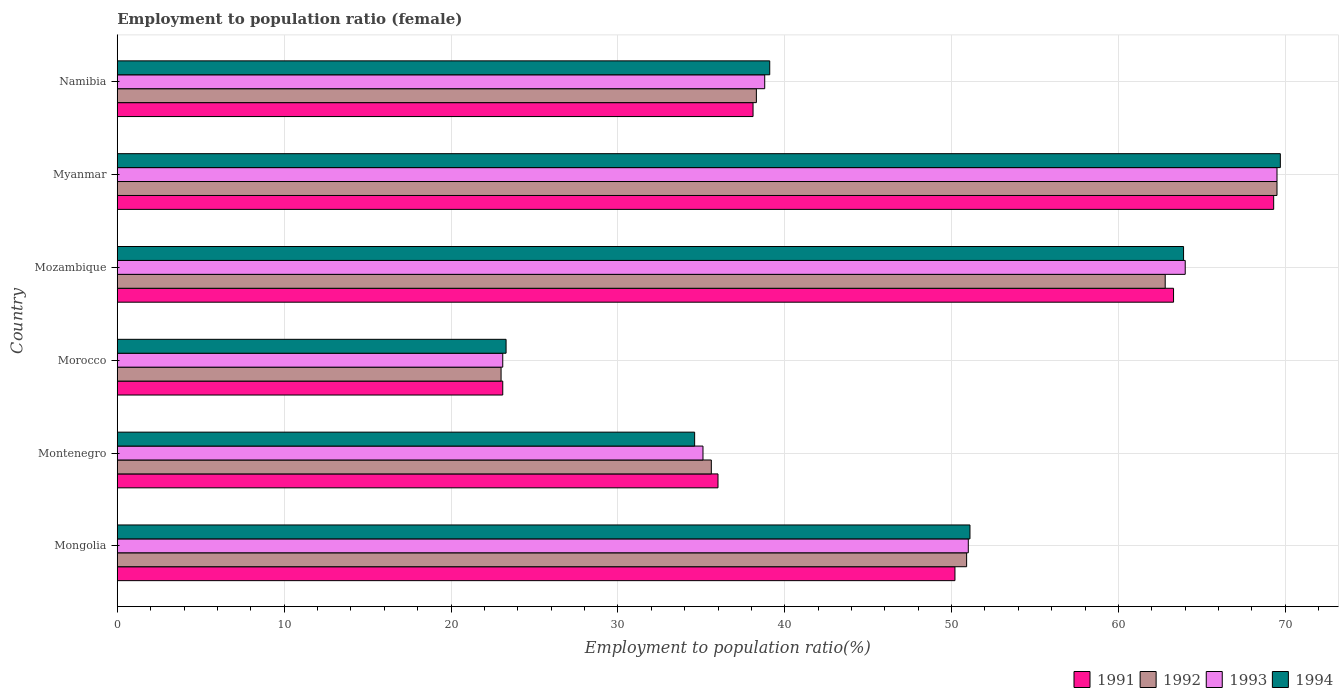How many groups of bars are there?
Your answer should be compact. 6. Are the number of bars on each tick of the Y-axis equal?
Keep it short and to the point. Yes. How many bars are there on the 4th tick from the top?
Your answer should be compact. 4. How many bars are there on the 6th tick from the bottom?
Provide a succinct answer. 4. What is the label of the 6th group of bars from the top?
Ensure brevity in your answer.  Mongolia. What is the employment to population ratio in 1992 in Mozambique?
Your answer should be very brief. 62.8. Across all countries, what is the maximum employment to population ratio in 1994?
Provide a succinct answer. 69.7. Across all countries, what is the minimum employment to population ratio in 1993?
Keep it short and to the point. 23.1. In which country was the employment to population ratio in 1993 maximum?
Your response must be concise. Myanmar. In which country was the employment to population ratio in 1993 minimum?
Make the answer very short. Morocco. What is the total employment to population ratio in 1993 in the graph?
Ensure brevity in your answer.  281.5. What is the difference between the employment to population ratio in 1991 in Namibia and the employment to population ratio in 1992 in Mongolia?
Ensure brevity in your answer.  -12.8. What is the average employment to population ratio in 1991 per country?
Keep it short and to the point. 46.67. What is the difference between the employment to population ratio in 1992 and employment to population ratio in 1994 in Morocco?
Offer a terse response. -0.3. In how many countries, is the employment to population ratio in 1991 greater than 60 %?
Ensure brevity in your answer.  2. What is the ratio of the employment to population ratio in 1994 in Morocco to that in Myanmar?
Offer a terse response. 0.33. Is the difference between the employment to population ratio in 1992 in Montenegro and Namibia greater than the difference between the employment to population ratio in 1994 in Montenegro and Namibia?
Offer a very short reply. Yes. What is the difference between the highest and the second highest employment to population ratio in 1992?
Your answer should be compact. 6.7. What is the difference between the highest and the lowest employment to population ratio in 1991?
Offer a terse response. 46.2. Is it the case that in every country, the sum of the employment to population ratio in 1993 and employment to population ratio in 1991 is greater than the sum of employment to population ratio in 1992 and employment to population ratio in 1994?
Your answer should be very brief. No. What does the 1st bar from the top in Myanmar represents?
Make the answer very short. 1994. Is it the case that in every country, the sum of the employment to population ratio in 1991 and employment to population ratio in 1992 is greater than the employment to population ratio in 1993?
Offer a terse response. Yes. Are the values on the major ticks of X-axis written in scientific E-notation?
Your answer should be compact. No. Does the graph contain any zero values?
Give a very brief answer. No. What is the title of the graph?
Offer a very short reply. Employment to population ratio (female). Does "1970" appear as one of the legend labels in the graph?
Make the answer very short. No. What is the Employment to population ratio(%) of 1991 in Mongolia?
Give a very brief answer. 50.2. What is the Employment to population ratio(%) of 1992 in Mongolia?
Give a very brief answer. 50.9. What is the Employment to population ratio(%) of 1994 in Mongolia?
Your answer should be compact. 51.1. What is the Employment to population ratio(%) in 1992 in Montenegro?
Make the answer very short. 35.6. What is the Employment to population ratio(%) of 1993 in Montenegro?
Make the answer very short. 35.1. What is the Employment to population ratio(%) in 1994 in Montenegro?
Make the answer very short. 34.6. What is the Employment to population ratio(%) of 1991 in Morocco?
Give a very brief answer. 23.1. What is the Employment to population ratio(%) of 1993 in Morocco?
Your response must be concise. 23.1. What is the Employment to population ratio(%) in 1994 in Morocco?
Ensure brevity in your answer.  23.3. What is the Employment to population ratio(%) in 1991 in Mozambique?
Provide a succinct answer. 63.3. What is the Employment to population ratio(%) of 1992 in Mozambique?
Offer a terse response. 62.8. What is the Employment to population ratio(%) of 1993 in Mozambique?
Give a very brief answer. 64. What is the Employment to population ratio(%) of 1994 in Mozambique?
Your response must be concise. 63.9. What is the Employment to population ratio(%) of 1991 in Myanmar?
Keep it short and to the point. 69.3. What is the Employment to population ratio(%) of 1992 in Myanmar?
Keep it short and to the point. 69.5. What is the Employment to population ratio(%) in 1993 in Myanmar?
Your answer should be very brief. 69.5. What is the Employment to population ratio(%) of 1994 in Myanmar?
Offer a very short reply. 69.7. What is the Employment to population ratio(%) of 1991 in Namibia?
Your answer should be compact. 38.1. What is the Employment to population ratio(%) of 1992 in Namibia?
Keep it short and to the point. 38.3. What is the Employment to population ratio(%) in 1993 in Namibia?
Ensure brevity in your answer.  38.8. What is the Employment to population ratio(%) in 1994 in Namibia?
Make the answer very short. 39.1. Across all countries, what is the maximum Employment to population ratio(%) of 1991?
Offer a very short reply. 69.3. Across all countries, what is the maximum Employment to population ratio(%) in 1992?
Offer a very short reply. 69.5. Across all countries, what is the maximum Employment to population ratio(%) of 1993?
Your answer should be very brief. 69.5. Across all countries, what is the maximum Employment to population ratio(%) of 1994?
Give a very brief answer. 69.7. Across all countries, what is the minimum Employment to population ratio(%) of 1991?
Make the answer very short. 23.1. Across all countries, what is the minimum Employment to population ratio(%) in 1993?
Your answer should be very brief. 23.1. Across all countries, what is the minimum Employment to population ratio(%) of 1994?
Your response must be concise. 23.3. What is the total Employment to population ratio(%) of 1991 in the graph?
Provide a succinct answer. 280. What is the total Employment to population ratio(%) of 1992 in the graph?
Provide a succinct answer. 280.1. What is the total Employment to population ratio(%) in 1993 in the graph?
Offer a very short reply. 281.5. What is the total Employment to population ratio(%) in 1994 in the graph?
Provide a succinct answer. 281.7. What is the difference between the Employment to population ratio(%) of 1992 in Mongolia and that in Montenegro?
Provide a succinct answer. 15.3. What is the difference between the Employment to population ratio(%) of 1994 in Mongolia and that in Montenegro?
Your response must be concise. 16.5. What is the difference between the Employment to population ratio(%) of 1991 in Mongolia and that in Morocco?
Offer a terse response. 27.1. What is the difference between the Employment to population ratio(%) in 1992 in Mongolia and that in Morocco?
Your response must be concise. 27.9. What is the difference between the Employment to population ratio(%) in 1993 in Mongolia and that in Morocco?
Ensure brevity in your answer.  27.9. What is the difference between the Employment to population ratio(%) in 1994 in Mongolia and that in Morocco?
Keep it short and to the point. 27.8. What is the difference between the Employment to population ratio(%) in 1992 in Mongolia and that in Mozambique?
Your answer should be very brief. -11.9. What is the difference between the Employment to population ratio(%) in 1993 in Mongolia and that in Mozambique?
Give a very brief answer. -13. What is the difference between the Employment to population ratio(%) of 1994 in Mongolia and that in Mozambique?
Provide a succinct answer. -12.8. What is the difference between the Employment to population ratio(%) of 1991 in Mongolia and that in Myanmar?
Keep it short and to the point. -19.1. What is the difference between the Employment to population ratio(%) of 1992 in Mongolia and that in Myanmar?
Your answer should be very brief. -18.6. What is the difference between the Employment to population ratio(%) in 1993 in Mongolia and that in Myanmar?
Give a very brief answer. -18.5. What is the difference between the Employment to population ratio(%) in 1994 in Mongolia and that in Myanmar?
Offer a very short reply. -18.6. What is the difference between the Employment to population ratio(%) of 1993 in Mongolia and that in Namibia?
Your response must be concise. 12.2. What is the difference between the Employment to population ratio(%) in 1991 in Montenegro and that in Morocco?
Your answer should be compact. 12.9. What is the difference between the Employment to population ratio(%) in 1993 in Montenegro and that in Morocco?
Ensure brevity in your answer.  12. What is the difference between the Employment to population ratio(%) in 1991 in Montenegro and that in Mozambique?
Offer a very short reply. -27.3. What is the difference between the Employment to population ratio(%) of 1992 in Montenegro and that in Mozambique?
Your response must be concise. -27.2. What is the difference between the Employment to population ratio(%) of 1993 in Montenegro and that in Mozambique?
Your response must be concise. -28.9. What is the difference between the Employment to population ratio(%) of 1994 in Montenegro and that in Mozambique?
Make the answer very short. -29.3. What is the difference between the Employment to population ratio(%) in 1991 in Montenegro and that in Myanmar?
Provide a succinct answer. -33.3. What is the difference between the Employment to population ratio(%) in 1992 in Montenegro and that in Myanmar?
Make the answer very short. -33.9. What is the difference between the Employment to population ratio(%) in 1993 in Montenegro and that in Myanmar?
Provide a succinct answer. -34.4. What is the difference between the Employment to population ratio(%) of 1994 in Montenegro and that in Myanmar?
Provide a short and direct response. -35.1. What is the difference between the Employment to population ratio(%) in 1991 in Montenegro and that in Namibia?
Provide a succinct answer. -2.1. What is the difference between the Employment to population ratio(%) of 1993 in Montenegro and that in Namibia?
Your answer should be compact. -3.7. What is the difference between the Employment to population ratio(%) in 1994 in Montenegro and that in Namibia?
Ensure brevity in your answer.  -4.5. What is the difference between the Employment to population ratio(%) of 1991 in Morocco and that in Mozambique?
Make the answer very short. -40.2. What is the difference between the Employment to population ratio(%) in 1992 in Morocco and that in Mozambique?
Your response must be concise. -39.8. What is the difference between the Employment to population ratio(%) of 1993 in Morocco and that in Mozambique?
Ensure brevity in your answer.  -40.9. What is the difference between the Employment to population ratio(%) of 1994 in Morocco and that in Mozambique?
Offer a terse response. -40.6. What is the difference between the Employment to population ratio(%) in 1991 in Morocco and that in Myanmar?
Provide a short and direct response. -46.2. What is the difference between the Employment to population ratio(%) of 1992 in Morocco and that in Myanmar?
Offer a very short reply. -46.5. What is the difference between the Employment to population ratio(%) in 1993 in Morocco and that in Myanmar?
Provide a short and direct response. -46.4. What is the difference between the Employment to population ratio(%) of 1994 in Morocco and that in Myanmar?
Offer a very short reply. -46.4. What is the difference between the Employment to population ratio(%) of 1991 in Morocco and that in Namibia?
Your answer should be compact. -15. What is the difference between the Employment to population ratio(%) in 1992 in Morocco and that in Namibia?
Offer a terse response. -15.3. What is the difference between the Employment to population ratio(%) of 1993 in Morocco and that in Namibia?
Provide a short and direct response. -15.7. What is the difference between the Employment to population ratio(%) in 1994 in Morocco and that in Namibia?
Make the answer very short. -15.8. What is the difference between the Employment to population ratio(%) in 1993 in Mozambique and that in Myanmar?
Your answer should be very brief. -5.5. What is the difference between the Employment to population ratio(%) of 1991 in Mozambique and that in Namibia?
Offer a very short reply. 25.2. What is the difference between the Employment to population ratio(%) in 1993 in Mozambique and that in Namibia?
Provide a succinct answer. 25.2. What is the difference between the Employment to population ratio(%) in 1994 in Mozambique and that in Namibia?
Your response must be concise. 24.8. What is the difference between the Employment to population ratio(%) in 1991 in Myanmar and that in Namibia?
Give a very brief answer. 31.2. What is the difference between the Employment to population ratio(%) of 1992 in Myanmar and that in Namibia?
Keep it short and to the point. 31.2. What is the difference between the Employment to population ratio(%) of 1993 in Myanmar and that in Namibia?
Provide a succinct answer. 30.7. What is the difference between the Employment to population ratio(%) of 1994 in Myanmar and that in Namibia?
Make the answer very short. 30.6. What is the difference between the Employment to population ratio(%) of 1991 in Mongolia and the Employment to population ratio(%) of 1994 in Montenegro?
Your response must be concise. 15.6. What is the difference between the Employment to population ratio(%) in 1992 in Mongolia and the Employment to population ratio(%) in 1993 in Montenegro?
Offer a very short reply. 15.8. What is the difference between the Employment to population ratio(%) of 1993 in Mongolia and the Employment to population ratio(%) of 1994 in Montenegro?
Keep it short and to the point. 16.4. What is the difference between the Employment to population ratio(%) of 1991 in Mongolia and the Employment to population ratio(%) of 1992 in Morocco?
Your response must be concise. 27.2. What is the difference between the Employment to population ratio(%) of 1991 in Mongolia and the Employment to population ratio(%) of 1993 in Morocco?
Make the answer very short. 27.1. What is the difference between the Employment to population ratio(%) in 1991 in Mongolia and the Employment to population ratio(%) in 1994 in Morocco?
Keep it short and to the point. 26.9. What is the difference between the Employment to population ratio(%) of 1992 in Mongolia and the Employment to population ratio(%) of 1993 in Morocco?
Your answer should be compact. 27.8. What is the difference between the Employment to population ratio(%) in 1992 in Mongolia and the Employment to population ratio(%) in 1994 in Morocco?
Make the answer very short. 27.6. What is the difference between the Employment to population ratio(%) in 1993 in Mongolia and the Employment to population ratio(%) in 1994 in Morocco?
Ensure brevity in your answer.  27.7. What is the difference between the Employment to population ratio(%) in 1991 in Mongolia and the Employment to population ratio(%) in 1992 in Mozambique?
Your answer should be compact. -12.6. What is the difference between the Employment to population ratio(%) in 1991 in Mongolia and the Employment to population ratio(%) in 1994 in Mozambique?
Provide a short and direct response. -13.7. What is the difference between the Employment to population ratio(%) of 1992 in Mongolia and the Employment to population ratio(%) of 1993 in Mozambique?
Offer a terse response. -13.1. What is the difference between the Employment to population ratio(%) in 1993 in Mongolia and the Employment to population ratio(%) in 1994 in Mozambique?
Keep it short and to the point. -12.9. What is the difference between the Employment to population ratio(%) of 1991 in Mongolia and the Employment to population ratio(%) of 1992 in Myanmar?
Make the answer very short. -19.3. What is the difference between the Employment to population ratio(%) in 1991 in Mongolia and the Employment to population ratio(%) in 1993 in Myanmar?
Make the answer very short. -19.3. What is the difference between the Employment to population ratio(%) of 1991 in Mongolia and the Employment to population ratio(%) of 1994 in Myanmar?
Your answer should be compact. -19.5. What is the difference between the Employment to population ratio(%) in 1992 in Mongolia and the Employment to population ratio(%) in 1993 in Myanmar?
Your answer should be compact. -18.6. What is the difference between the Employment to population ratio(%) of 1992 in Mongolia and the Employment to population ratio(%) of 1994 in Myanmar?
Your answer should be very brief. -18.8. What is the difference between the Employment to population ratio(%) of 1993 in Mongolia and the Employment to population ratio(%) of 1994 in Myanmar?
Make the answer very short. -18.7. What is the difference between the Employment to population ratio(%) of 1991 in Mongolia and the Employment to population ratio(%) of 1993 in Namibia?
Your answer should be very brief. 11.4. What is the difference between the Employment to population ratio(%) in 1991 in Mongolia and the Employment to population ratio(%) in 1994 in Namibia?
Your answer should be compact. 11.1. What is the difference between the Employment to population ratio(%) of 1992 in Mongolia and the Employment to population ratio(%) of 1993 in Namibia?
Make the answer very short. 12.1. What is the difference between the Employment to population ratio(%) of 1991 in Montenegro and the Employment to population ratio(%) of 1992 in Morocco?
Provide a short and direct response. 13. What is the difference between the Employment to population ratio(%) in 1992 in Montenegro and the Employment to population ratio(%) in 1994 in Morocco?
Keep it short and to the point. 12.3. What is the difference between the Employment to population ratio(%) in 1993 in Montenegro and the Employment to population ratio(%) in 1994 in Morocco?
Make the answer very short. 11.8. What is the difference between the Employment to population ratio(%) in 1991 in Montenegro and the Employment to population ratio(%) in 1992 in Mozambique?
Offer a terse response. -26.8. What is the difference between the Employment to population ratio(%) of 1991 in Montenegro and the Employment to population ratio(%) of 1994 in Mozambique?
Provide a succinct answer. -27.9. What is the difference between the Employment to population ratio(%) in 1992 in Montenegro and the Employment to population ratio(%) in 1993 in Mozambique?
Offer a terse response. -28.4. What is the difference between the Employment to population ratio(%) of 1992 in Montenegro and the Employment to population ratio(%) of 1994 in Mozambique?
Provide a short and direct response. -28.3. What is the difference between the Employment to population ratio(%) of 1993 in Montenegro and the Employment to population ratio(%) of 1994 in Mozambique?
Offer a very short reply. -28.8. What is the difference between the Employment to population ratio(%) of 1991 in Montenegro and the Employment to population ratio(%) of 1992 in Myanmar?
Offer a very short reply. -33.5. What is the difference between the Employment to population ratio(%) of 1991 in Montenegro and the Employment to population ratio(%) of 1993 in Myanmar?
Offer a terse response. -33.5. What is the difference between the Employment to population ratio(%) in 1991 in Montenegro and the Employment to population ratio(%) in 1994 in Myanmar?
Your answer should be compact. -33.7. What is the difference between the Employment to population ratio(%) of 1992 in Montenegro and the Employment to population ratio(%) of 1993 in Myanmar?
Make the answer very short. -33.9. What is the difference between the Employment to population ratio(%) of 1992 in Montenegro and the Employment to population ratio(%) of 1994 in Myanmar?
Offer a very short reply. -34.1. What is the difference between the Employment to population ratio(%) in 1993 in Montenegro and the Employment to population ratio(%) in 1994 in Myanmar?
Keep it short and to the point. -34.6. What is the difference between the Employment to population ratio(%) in 1991 in Montenegro and the Employment to population ratio(%) in 1992 in Namibia?
Offer a very short reply. -2.3. What is the difference between the Employment to population ratio(%) of 1991 in Montenegro and the Employment to population ratio(%) of 1993 in Namibia?
Your answer should be compact. -2.8. What is the difference between the Employment to population ratio(%) in 1991 in Montenegro and the Employment to population ratio(%) in 1994 in Namibia?
Make the answer very short. -3.1. What is the difference between the Employment to population ratio(%) in 1992 in Montenegro and the Employment to population ratio(%) in 1993 in Namibia?
Provide a succinct answer. -3.2. What is the difference between the Employment to population ratio(%) in 1992 in Montenegro and the Employment to population ratio(%) in 1994 in Namibia?
Provide a short and direct response. -3.5. What is the difference between the Employment to population ratio(%) of 1991 in Morocco and the Employment to population ratio(%) of 1992 in Mozambique?
Make the answer very short. -39.7. What is the difference between the Employment to population ratio(%) in 1991 in Morocco and the Employment to population ratio(%) in 1993 in Mozambique?
Provide a short and direct response. -40.9. What is the difference between the Employment to population ratio(%) of 1991 in Morocco and the Employment to population ratio(%) of 1994 in Mozambique?
Your answer should be very brief. -40.8. What is the difference between the Employment to population ratio(%) in 1992 in Morocco and the Employment to population ratio(%) in 1993 in Mozambique?
Your response must be concise. -41. What is the difference between the Employment to population ratio(%) in 1992 in Morocco and the Employment to population ratio(%) in 1994 in Mozambique?
Offer a terse response. -40.9. What is the difference between the Employment to population ratio(%) of 1993 in Morocco and the Employment to population ratio(%) of 1994 in Mozambique?
Your answer should be very brief. -40.8. What is the difference between the Employment to population ratio(%) in 1991 in Morocco and the Employment to population ratio(%) in 1992 in Myanmar?
Your response must be concise. -46.4. What is the difference between the Employment to population ratio(%) in 1991 in Morocco and the Employment to population ratio(%) in 1993 in Myanmar?
Offer a very short reply. -46.4. What is the difference between the Employment to population ratio(%) of 1991 in Morocco and the Employment to population ratio(%) of 1994 in Myanmar?
Offer a terse response. -46.6. What is the difference between the Employment to population ratio(%) in 1992 in Morocco and the Employment to population ratio(%) in 1993 in Myanmar?
Provide a succinct answer. -46.5. What is the difference between the Employment to population ratio(%) of 1992 in Morocco and the Employment to population ratio(%) of 1994 in Myanmar?
Make the answer very short. -46.7. What is the difference between the Employment to population ratio(%) in 1993 in Morocco and the Employment to population ratio(%) in 1994 in Myanmar?
Give a very brief answer. -46.6. What is the difference between the Employment to population ratio(%) of 1991 in Morocco and the Employment to population ratio(%) of 1992 in Namibia?
Keep it short and to the point. -15.2. What is the difference between the Employment to population ratio(%) of 1991 in Morocco and the Employment to population ratio(%) of 1993 in Namibia?
Your answer should be compact. -15.7. What is the difference between the Employment to population ratio(%) in 1992 in Morocco and the Employment to population ratio(%) in 1993 in Namibia?
Ensure brevity in your answer.  -15.8. What is the difference between the Employment to population ratio(%) in 1992 in Morocco and the Employment to population ratio(%) in 1994 in Namibia?
Provide a succinct answer. -16.1. What is the difference between the Employment to population ratio(%) of 1991 in Mozambique and the Employment to population ratio(%) of 1992 in Myanmar?
Make the answer very short. -6.2. What is the difference between the Employment to population ratio(%) in 1991 in Mozambique and the Employment to population ratio(%) in 1993 in Myanmar?
Keep it short and to the point. -6.2. What is the difference between the Employment to population ratio(%) in 1991 in Mozambique and the Employment to population ratio(%) in 1992 in Namibia?
Provide a short and direct response. 25. What is the difference between the Employment to population ratio(%) in 1991 in Mozambique and the Employment to population ratio(%) in 1994 in Namibia?
Your answer should be compact. 24.2. What is the difference between the Employment to population ratio(%) of 1992 in Mozambique and the Employment to population ratio(%) of 1994 in Namibia?
Give a very brief answer. 23.7. What is the difference between the Employment to population ratio(%) in 1993 in Mozambique and the Employment to population ratio(%) in 1994 in Namibia?
Make the answer very short. 24.9. What is the difference between the Employment to population ratio(%) in 1991 in Myanmar and the Employment to population ratio(%) in 1992 in Namibia?
Make the answer very short. 31. What is the difference between the Employment to population ratio(%) in 1991 in Myanmar and the Employment to population ratio(%) in 1993 in Namibia?
Ensure brevity in your answer.  30.5. What is the difference between the Employment to population ratio(%) in 1991 in Myanmar and the Employment to population ratio(%) in 1994 in Namibia?
Your response must be concise. 30.2. What is the difference between the Employment to population ratio(%) of 1992 in Myanmar and the Employment to population ratio(%) of 1993 in Namibia?
Give a very brief answer. 30.7. What is the difference between the Employment to population ratio(%) in 1992 in Myanmar and the Employment to population ratio(%) in 1994 in Namibia?
Your answer should be compact. 30.4. What is the difference between the Employment to population ratio(%) in 1993 in Myanmar and the Employment to population ratio(%) in 1994 in Namibia?
Give a very brief answer. 30.4. What is the average Employment to population ratio(%) of 1991 per country?
Give a very brief answer. 46.67. What is the average Employment to population ratio(%) in 1992 per country?
Offer a terse response. 46.68. What is the average Employment to population ratio(%) in 1993 per country?
Provide a short and direct response. 46.92. What is the average Employment to population ratio(%) in 1994 per country?
Provide a short and direct response. 46.95. What is the difference between the Employment to population ratio(%) in 1991 and Employment to population ratio(%) in 1994 in Mongolia?
Offer a terse response. -0.9. What is the difference between the Employment to population ratio(%) of 1991 and Employment to population ratio(%) of 1993 in Montenegro?
Your answer should be very brief. 0.9. What is the difference between the Employment to population ratio(%) in 1992 and Employment to population ratio(%) in 1993 in Montenegro?
Your answer should be compact. 0.5. What is the difference between the Employment to population ratio(%) in 1993 and Employment to population ratio(%) in 1994 in Montenegro?
Ensure brevity in your answer.  0.5. What is the difference between the Employment to population ratio(%) in 1991 and Employment to population ratio(%) in 1994 in Morocco?
Offer a terse response. -0.2. What is the difference between the Employment to population ratio(%) in 1991 and Employment to population ratio(%) in 1993 in Mozambique?
Provide a succinct answer. -0.7. What is the difference between the Employment to population ratio(%) in 1992 and Employment to population ratio(%) in 1993 in Mozambique?
Make the answer very short. -1.2. What is the difference between the Employment to population ratio(%) in 1991 and Employment to population ratio(%) in 1994 in Myanmar?
Your response must be concise. -0.4. What is the difference between the Employment to population ratio(%) in 1991 and Employment to population ratio(%) in 1992 in Namibia?
Your answer should be compact. -0.2. What is the difference between the Employment to population ratio(%) in 1991 and Employment to population ratio(%) in 1993 in Namibia?
Ensure brevity in your answer.  -0.7. What is the difference between the Employment to population ratio(%) in 1992 and Employment to population ratio(%) in 1993 in Namibia?
Offer a terse response. -0.5. What is the ratio of the Employment to population ratio(%) in 1991 in Mongolia to that in Montenegro?
Your answer should be compact. 1.39. What is the ratio of the Employment to population ratio(%) of 1992 in Mongolia to that in Montenegro?
Give a very brief answer. 1.43. What is the ratio of the Employment to population ratio(%) in 1993 in Mongolia to that in Montenegro?
Provide a short and direct response. 1.45. What is the ratio of the Employment to population ratio(%) in 1994 in Mongolia to that in Montenegro?
Ensure brevity in your answer.  1.48. What is the ratio of the Employment to population ratio(%) in 1991 in Mongolia to that in Morocco?
Offer a very short reply. 2.17. What is the ratio of the Employment to population ratio(%) in 1992 in Mongolia to that in Morocco?
Your answer should be compact. 2.21. What is the ratio of the Employment to population ratio(%) of 1993 in Mongolia to that in Morocco?
Your response must be concise. 2.21. What is the ratio of the Employment to population ratio(%) in 1994 in Mongolia to that in Morocco?
Provide a short and direct response. 2.19. What is the ratio of the Employment to population ratio(%) in 1991 in Mongolia to that in Mozambique?
Offer a terse response. 0.79. What is the ratio of the Employment to population ratio(%) in 1992 in Mongolia to that in Mozambique?
Offer a very short reply. 0.81. What is the ratio of the Employment to population ratio(%) of 1993 in Mongolia to that in Mozambique?
Ensure brevity in your answer.  0.8. What is the ratio of the Employment to population ratio(%) in 1994 in Mongolia to that in Mozambique?
Ensure brevity in your answer.  0.8. What is the ratio of the Employment to population ratio(%) in 1991 in Mongolia to that in Myanmar?
Keep it short and to the point. 0.72. What is the ratio of the Employment to population ratio(%) in 1992 in Mongolia to that in Myanmar?
Keep it short and to the point. 0.73. What is the ratio of the Employment to population ratio(%) in 1993 in Mongolia to that in Myanmar?
Your answer should be compact. 0.73. What is the ratio of the Employment to population ratio(%) of 1994 in Mongolia to that in Myanmar?
Offer a terse response. 0.73. What is the ratio of the Employment to population ratio(%) of 1991 in Mongolia to that in Namibia?
Your answer should be very brief. 1.32. What is the ratio of the Employment to population ratio(%) in 1992 in Mongolia to that in Namibia?
Offer a very short reply. 1.33. What is the ratio of the Employment to population ratio(%) of 1993 in Mongolia to that in Namibia?
Provide a short and direct response. 1.31. What is the ratio of the Employment to population ratio(%) of 1994 in Mongolia to that in Namibia?
Ensure brevity in your answer.  1.31. What is the ratio of the Employment to population ratio(%) of 1991 in Montenegro to that in Morocco?
Make the answer very short. 1.56. What is the ratio of the Employment to population ratio(%) of 1992 in Montenegro to that in Morocco?
Your response must be concise. 1.55. What is the ratio of the Employment to population ratio(%) of 1993 in Montenegro to that in Morocco?
Ensure brevity in your answer.  1.52. What is the ratio of the Employment to population ratio(%) of 1994 in Montenegro to that in Morocco?
Offer a very short reply. 1.49. What is the ratio of the Employment to population ratio(%) of 1991 in Montenegro to that in Mozambique?
Offer a terse response. 0.57. What is the ratio of the Employment to population ratio(%) in 1992 in Montenegro to that in Mozambique?
Ensure brevity in your answer.  0.57. What is the ratio of the Employment to population ratio(%) of 1993 in Montenegro to that in Mozambique?
Your response must be concise. 0.55. What is the ratio of the Employment to population ratio(%) of 1994 in Montenegro to that in Mozambique?
Your answer should be very brief. 0.54. What is the ratio of the Employment to population ratio(%) of 1991 in Montenegro to that in Myanmar?
Make the answer very short. 0.52. What is the ratio of the Employment to population ratio(%) in 1992 in Montenegro to that in Myanmar?
Ensure brevity in your answer.  0.51. What is the ratio of the Employment to population ratio(%) in 1993 in Montenegro to that in Myanmar?
Your response must be concise. 0.51. What is the ratio of the Employment to population ratio(%) in 1994 in Montenegro to that in Myanmar?
Your answer should be compact. 0.5. What is the ratio of the Employment to population ratio(%) of 1991 in Montenegro to that in Namibia?
Provide a short and direct response. 0.94. What is the ratio of the Employment to population ratio(%) in 1992 in Montenegro to that in Namibia?
Offer a terse response. 0.93. What is the ratio of the Employment to population ratio(%) of 1993 in Montenegro to that in Namibia?
Offer a terse response. 0.9. What is the ratio of the Employment to population ratio(%) of 1994 in Montenegro to that in Namibia?
Your answer should be compact. 0.88. What is the ratio of the Employment to population ratio(%) in 1991 in Morocco to that in Mozambique?
Make the answer very short. 0.36. What is the ratio of the Employment to population ratio(%) of 1992 in Morocco to that in Mozambique?
Make the answer very short. 0.37. What is the ratio of the Employment to population ratio(%) of 1993 in Morocco to that in Mozambique?
Give a very brief answer. 0.36. What is the ratio of the Employment to population ratio(%) of 1994 in Morocco to that in Mozambique?
Provide a short and direct response. 0.36. What is the ratio of the Employment to population ratio(%) in 1992 in Morocco to that in Myanmar?
Your answer should be compact. 0.33. What is the ratio of the Employment to population ratio(%) of 1993 in Morocco to that in Myanmar?
Ensure brevity in your answer.  0.33. What is the ratio of the Employment to population ratio(%) of 1994 in Morocco to that in Myanmar?
Provide a succinct answer. 0.33. What is the ratio of the Employment to population ratio(%) in 1991 in Morocco to that in Namibia?
Your response must be concise. 0.61. What is the ratio of the Employment to population ratio(%) of 1992 in Morocco to that in Namibia?
Provide a succinct answer. 0.6. What is the ratio of the Employment to population ratio(%) in 1993 in Morocco to that in Namibia?
Provide a succinct answer. 0.6. What is the ratio of the Employment to population ratio(%) of 1994 in Morocco to that in Namibia?
Ensure brevity in your answer.  0.6. What is the ratio of the Employment to population ratio(%) of 1991 in Mozambique to that in Myanmar?
Your response must be concise. 0.91. What is the ratio of the Employment to population ratio(%) of 1992 in Mozambique to that in Myanmar?
Your response must be concise. 0.9. What is the ratio of the Employment to population ratio(%) of 1993 in Mozambique to that in Myanmar?
Offer a terse response. 0.92. What is the ratio of the Employment to population ratio(%) in 1994 in Mozambique to that in Myanmar?
Your answer should be compact. 0.92. What is the ratio of the Employment to population ratio(%) in 1991 in Mozambique to that in Namibia?
Your response must be concise. 1.66. What is the ratio of the Employment to population ratio(%) of 1992 in Mozambique to that in Namibia?
Your answer should be very brief. 1.64. What is the ratio of the Employment to population ratio(%) of 1993 in Mozambique to that in Namibia?
Offer a terse response. 1.65. What is the ratio of the Employment to population ratio(%) of 1994 in Mozambique to that in Namibia?
Your response must be concise. 1.63. What is the ratio of the Employment to population ratio(%) in 1991 in Myanmar to that in Namibia?
Provide a short and direct response. 1.82. What is the ratio of the Employment to population ratio(%) of 1992 in Myanmar to that in Namibia?
Provide a succinct answer. 1.81. What is the ratio of the Employment to population ratio(%) in 1993 in Myanmar to that in Namibia?
Keep it short and to the point. 1.79. What is the ratio of the Employment to population ratio(%) in 1994 in Myanmar to that in Namibia?
Give a very brief answer. 1.78. What is the difference between the highest and the lowest Employment to population ratio(%) in 1991?
Ensure brevity in your answer.  46.2. What is the difference between the highest and the lowest Employment to population ratio(%) in 1992?
Your answer should be very brief. 46.5. What is the difference between the highest and the lowest Employment to population ratio(%) of 1993?
Your answer should be very brief. 46.4. What is the difference between the highest and the lowest Employment to population ratio(%) of 1994?
Give a very brief answer. 46.4. 